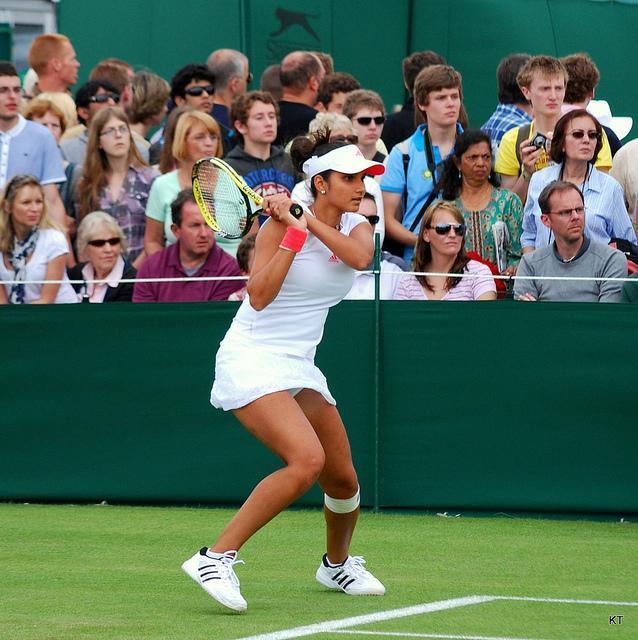How many people are wearing sunglasses?
Give a very brief answer. 6. How many people are in the picture?
Give a very brief answer. 14. 